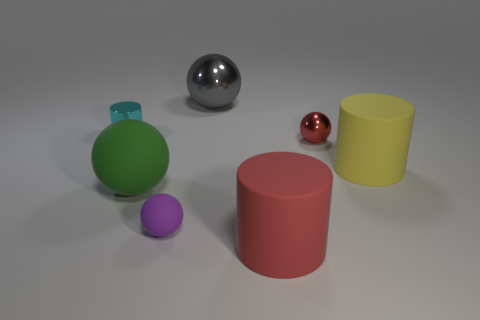Are there any other large rubber things that have the same shape as the cyan object?
Ensure brevity in your answer.  Yes. There is a yellow thing; does it have the same shape as the red object in front of the red ball?
Make the answer very short. Yes. What number of cubes are gray things or tiny purple matte things?
Your answer should be compact. 0. What shape is the red object behind the red cylinder?
Keep it short and to the point. Sphere. What number of red cylinders have the same material as the small cyan cylinder?
Offer a terse response. 0. Is the number of rubber things that are to the right of the green thing less than the number of tiny green rubber blocks?
Your response must be concise. No. There is a matte cylinder that is in front of the big rubber object on the right side of the red rubber cylinder; what size is it?
Keep it short and to the point. Large. Does the tiny metal ball have the same color as the matte cylinder on the left side of the red metal sphere?
Give a very brief answer. Yes. There is a purple object that is the same size as the cyan shiny thing; what material is it?
Make the answer very short. Rubber. Is the number of small shiny objects left of the tiny shiny cylinder less than the number of rubber balls in front of the red shiny sphere?
Keep it short and to the point. Yes. 